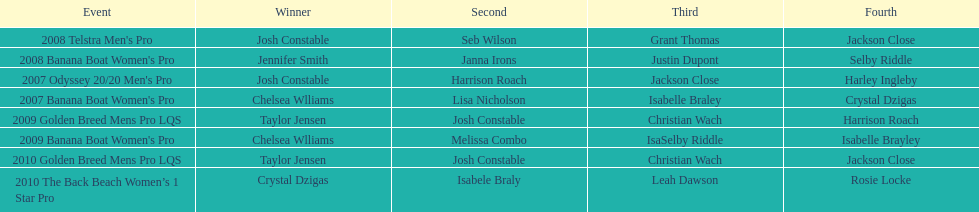Following josh constable's finish in the 2008 telstra men's pro, who was the next person to complete the race? Seb Wilson. 